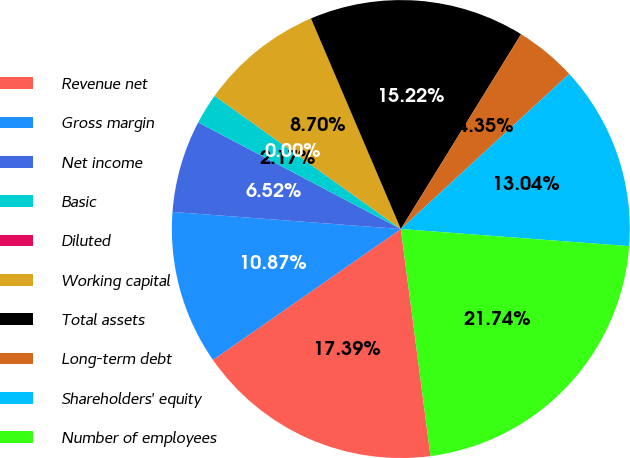Convert chart. <chart><loc_0><loc_0><loc_500><loc_500><pie_chart><fcel>Revenue net<fcel>Gross margin<fcel>Net income<fcel>Basic<fcel>Diluted<fcel>Working capital<fcel>Total assets<fcel>Long-term debt<fcel>Shareholders' equity<fcel>Number of employees<nl><fcel>17.39%<fcel>10.87%<fcel>6.52%<fcel>2.17%<fcel>0.0%<fcel>8.7%<fcel>15.22%<fcel>4.35%<fcel>13.04%<fcel>21.74%<nl></chart> 